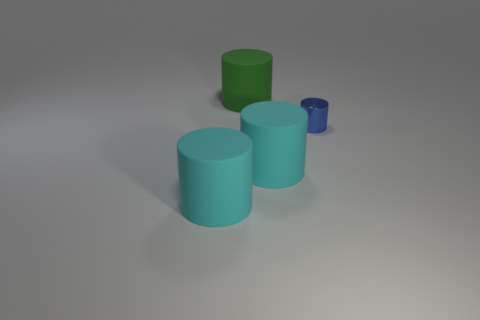How many shiny cylinders are there?
Make the answer very short. 1. There is a matte cylinder behind the blue cylinder; is it the same size as the cyan matte thing that is to the left of the big green object?
Give a very brief answer. Yes. There is another small thing that is the same shape as the green rubber thing; what color is it?
Your answer should be compact. Blue. Is the shape of the small blue object the same as the large green matte object?
Offer a very short reply. Yes. What is the size of the green object that is the same shape as the blue metal object?
Your response must be concise. Large. How many small things have the same material as the large green cylinder?
Keep it short and to the point. 0. How many objects are tiny purple metallic spheres or shiny things?
Keep it short and to the point. 1. Are there any objects that are to the left of the big matte cylinder behind the blue object?
Make the answer very short. Yes. Are there more big cyan matte things on the right side of the tiny thing than cyan matte things on the left side of the big green rubber object?
Give a very brief answer. No. How many matte objects have the same color as the small shiny thing?
Your response must be concise. 0. 